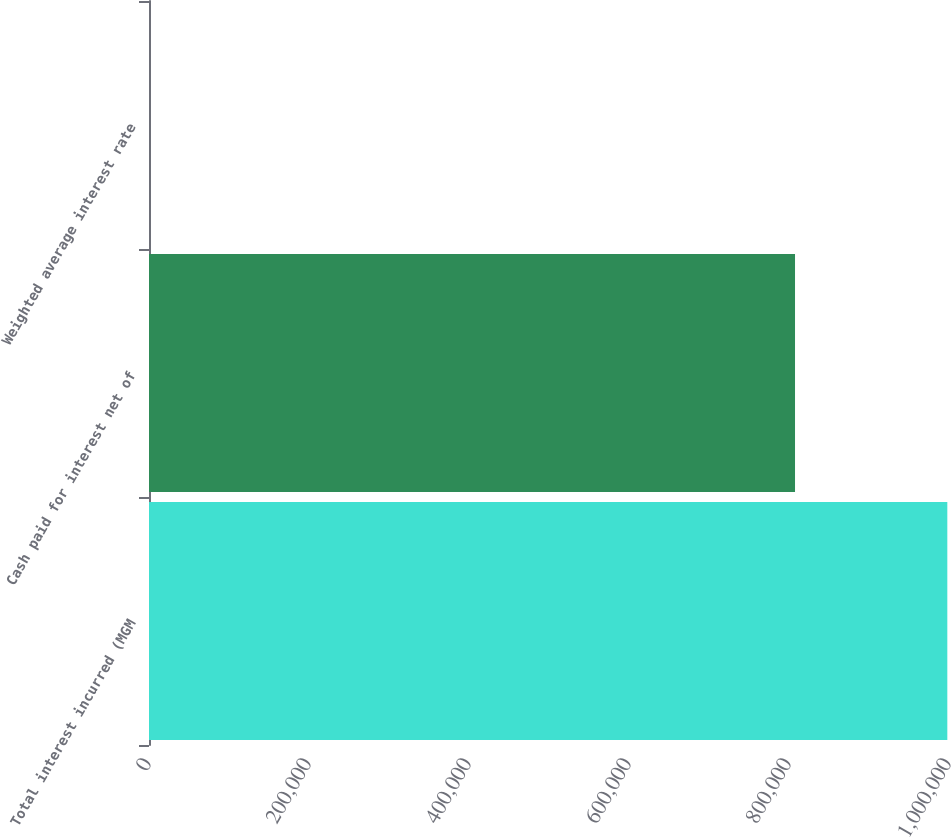Convert chart to OTSL. <chart><loc_0><loc_0><loc_500><loc_500><bar_chart><fcel>Total interest incurred (MGM<fcel>Cash paid for interest net of<fcel>Weighted average interest rate<nl><fcel>997897<fcel>807523<fcel>7.6<nl></chart> 